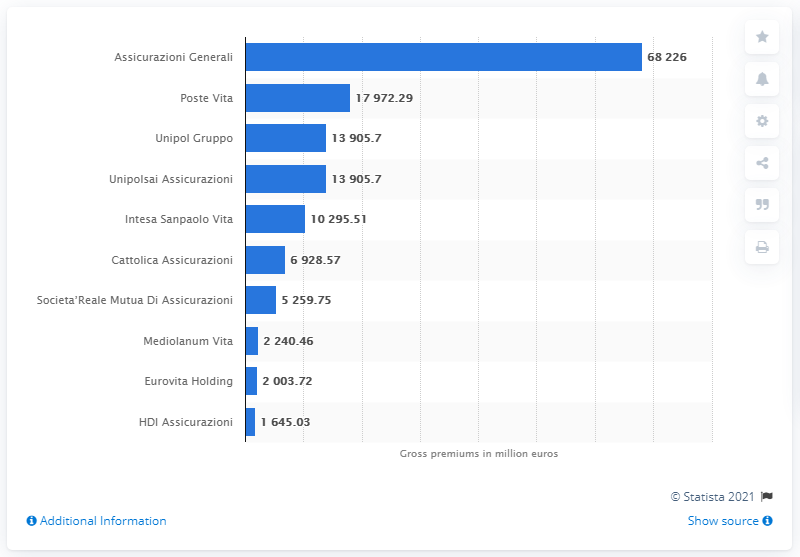Outline some significant characteristics in this image. The leading insurance group in Italy in terms of gross premiums written in 2019 was Assicurazioni Generali. Poste Vita reported a value of over 68 billion euros in 2019, which is a significant achievement. Assicurazioni Generali's premiums in both life and non-life segments totaled 68,226 in 2019. 